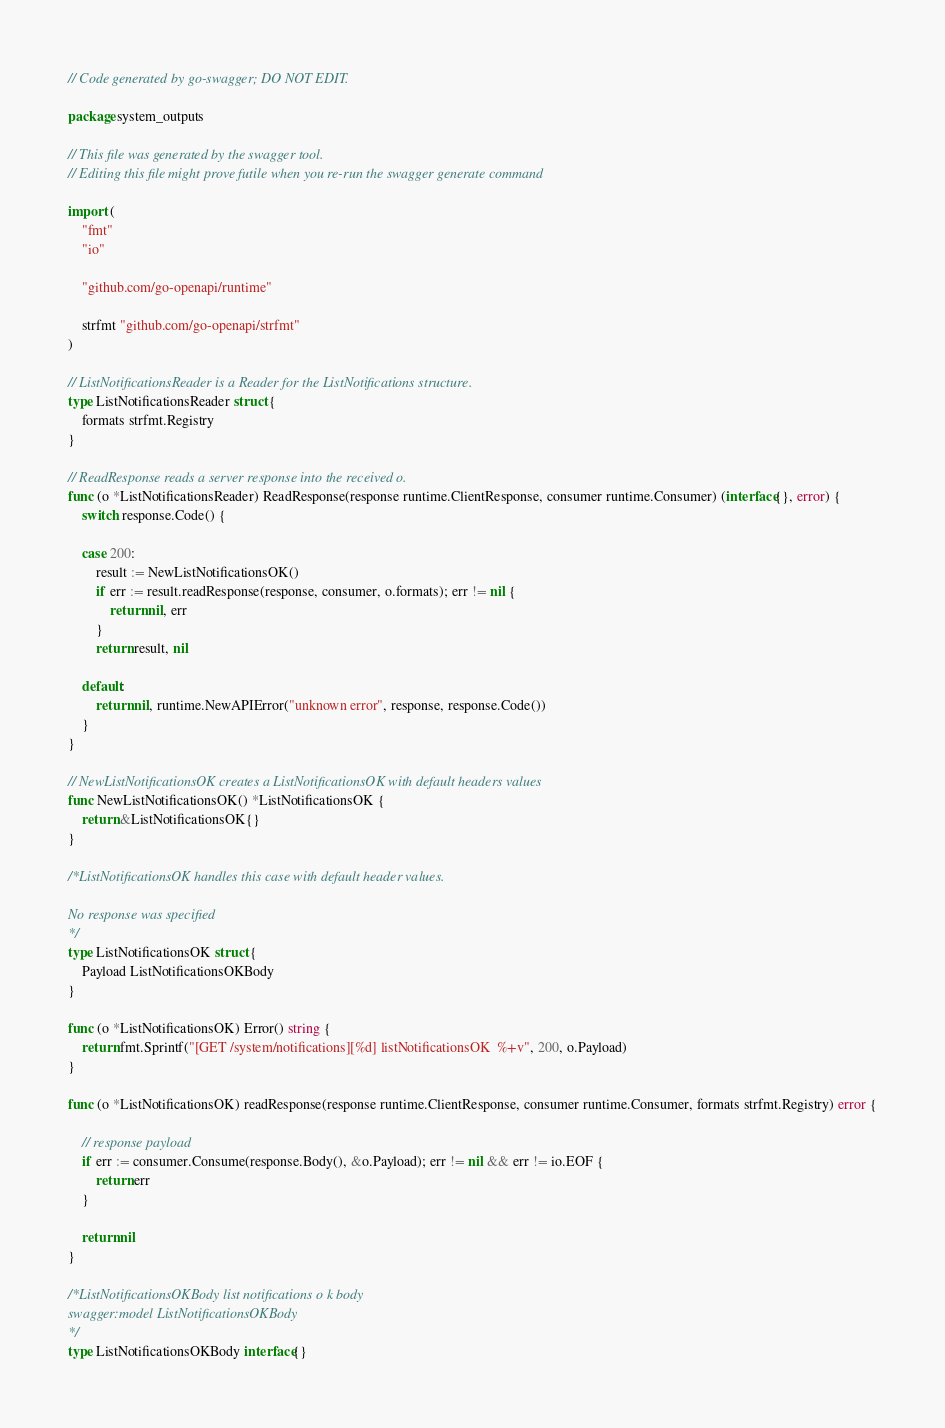<code> <loc_0><loc_0><loc_500><loc_500><_Go_>// Code generated by go-swagger; DO NOT EDIT.

package system_outputs

// This file was generated by the swagger tool.
// Editing this file might prove futile when you re-run the swagger generate command

import (
	"fmt"
	"io"

	"github.com/go-openapi/runtime"

	strfmt "github.com/go-openapi/strfmt"
)

// ListNotificationsReader is a Reader for the ListNotifications structure.
type ListNotificationsReader struct {
	formats strfmt.Registry
}

// ReadResponse reads a server response into the received o.
func (o *ListNotificationsReader) ReadResponse(response runtime.ClientResponse, consumer runtime.Consumer) (interface{}, error) {
	switch response.Code() {

	case 200:
		result := NewListNotificationsOK()
		if err := result.readResponse(response, consumer, o.formats); err != nil {
			return nil, err
		}
		return result, nil

	default:
		return nil, runtime.NewAPIError("unknown error", response, response.Code())
	}
}

// NewListNotificationsOK creates a ListNotificationsOK with default headers values
func NewListNotificationsOK() *ListNotificationsOK {
	return &ListNotificationsOK{}
}

/*ListNotificationsOK handles this case with default header values.

No response was specified
*/
type ListNotificationsOK struct {
	Payload ListNotificationsOKBody
}

func (o *ListNotificationsOK) Error() string {
	return fmt.Sprintf("[GET /system/notifications][%d] listNotificationsOK  %+v", 200, o.Payload)
}

func (o *ListNotificationsOK) readResponse(response runtime.ClientResponse, consumer runtime.Consumer, formats strfmt.Registry) error {

	// response payload
	if err := consumer.Consume(response.Body(), &o.Payload); err != nil && err != io.EOF {
		return err
	}

	return nil
}

/*ListNotificationsOKBody list notifications o k body
swagger:model ListNotificationsOKBody
*/
type ListNotificationsOKBody interface{}
</code> 